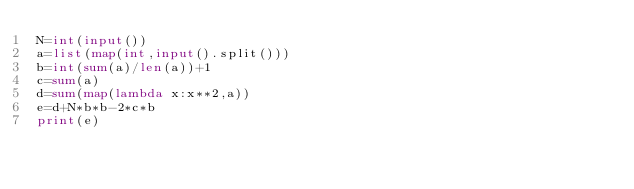<code> <loc_0><loc_0><loc_500><loc_500><_Python_>N=int(input())
a=list(map(int,input().split()))
b=int(sum(a)/len(a))+1
c=sum(a)
d=sum(map(lambda x:x**2,a))
e=d+N*b*b-2*c*b
print(e)</code> 